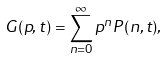<formula> <loc_0><loc_0><loc_500><loc_500>G ( p , t ) = \sum _ { n = 0 } ^ { \infty } p ^ { n } P ( n , t ) ,</formula> 